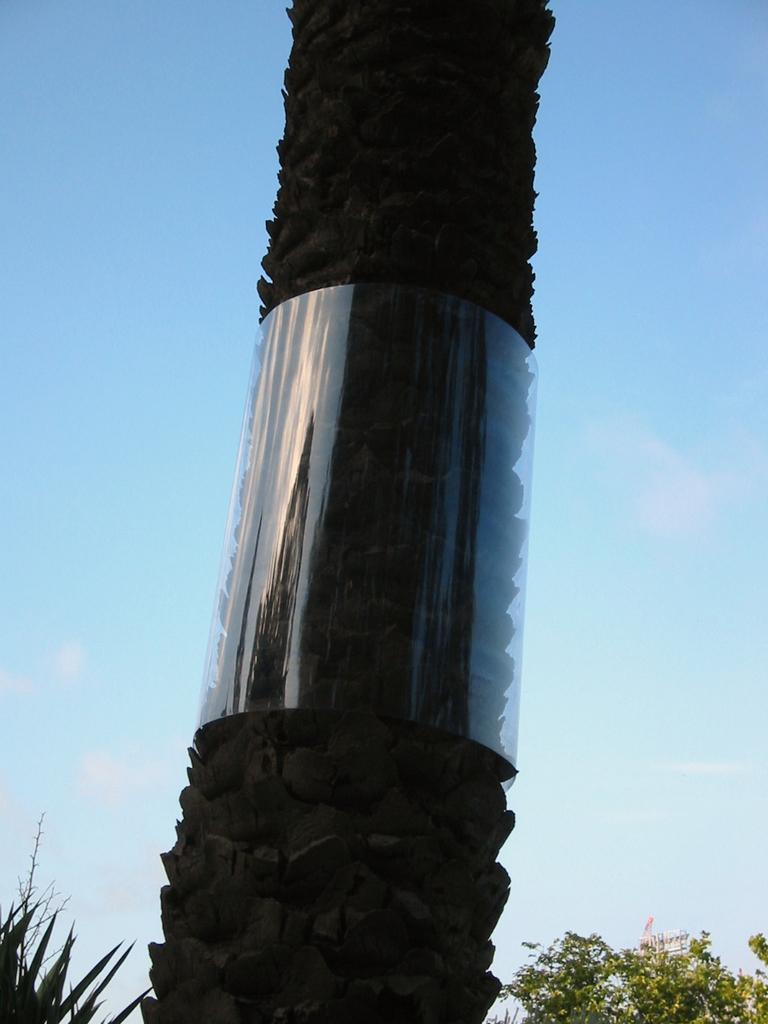What type of vegetation can be seen in the image? There are trees in the image. What can be seen in the sky in the image? There are clouds in the image. What type of paste is being used to hold the trees together in the image? There is no indication in the image that any paste is being used to hold the trees together; they are naturally growing plants. 